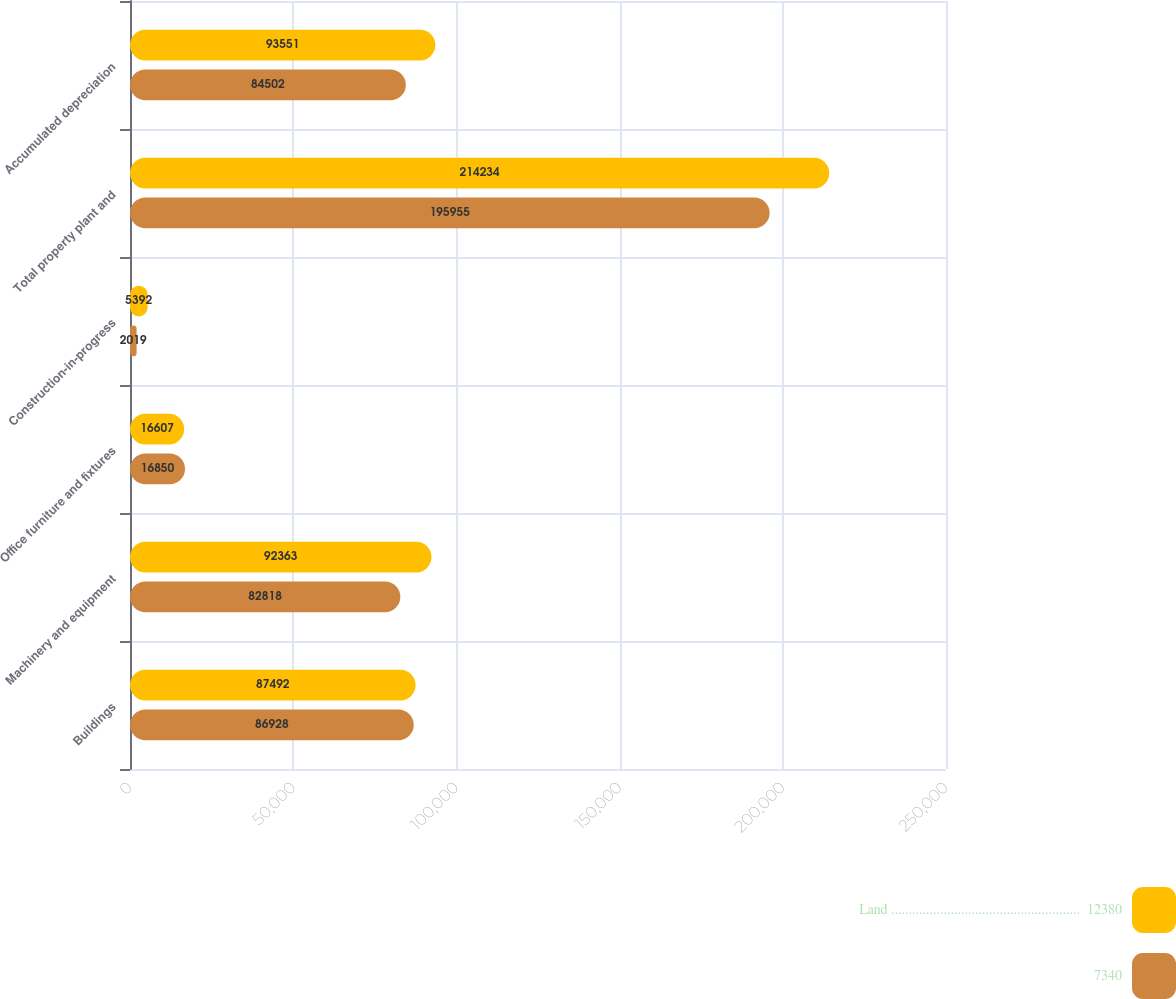<chart> <loc_0><loc_0><loc_500><loc_500><stacked_bar_chart><ecel><fcel>Buildings<fcel>Machinery and equipment<fcel>Office furniture and fixtures<fcel>Construction-in-progress<fcel>Total property plant and<fcel>Accumulated depreciation<nl><fcel>Land ......................................................  12380<fcel>87492<fcel>92363<fcel>16607<fcel>5392<fcel>214234<fcel>93551<nl><fcel>7340<fcel>86928<fcel>82818<fcel>16850<fcel>2019<fcel>195955<fcel>84502<nl></chart> 